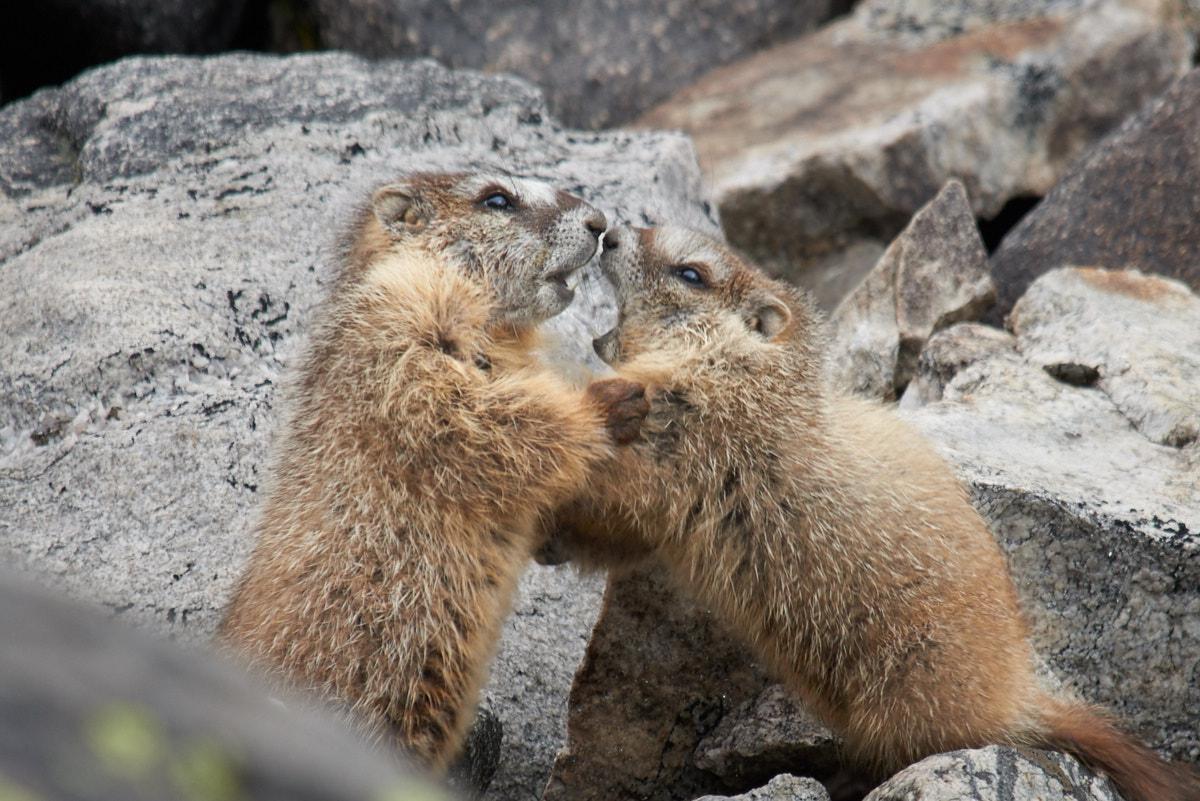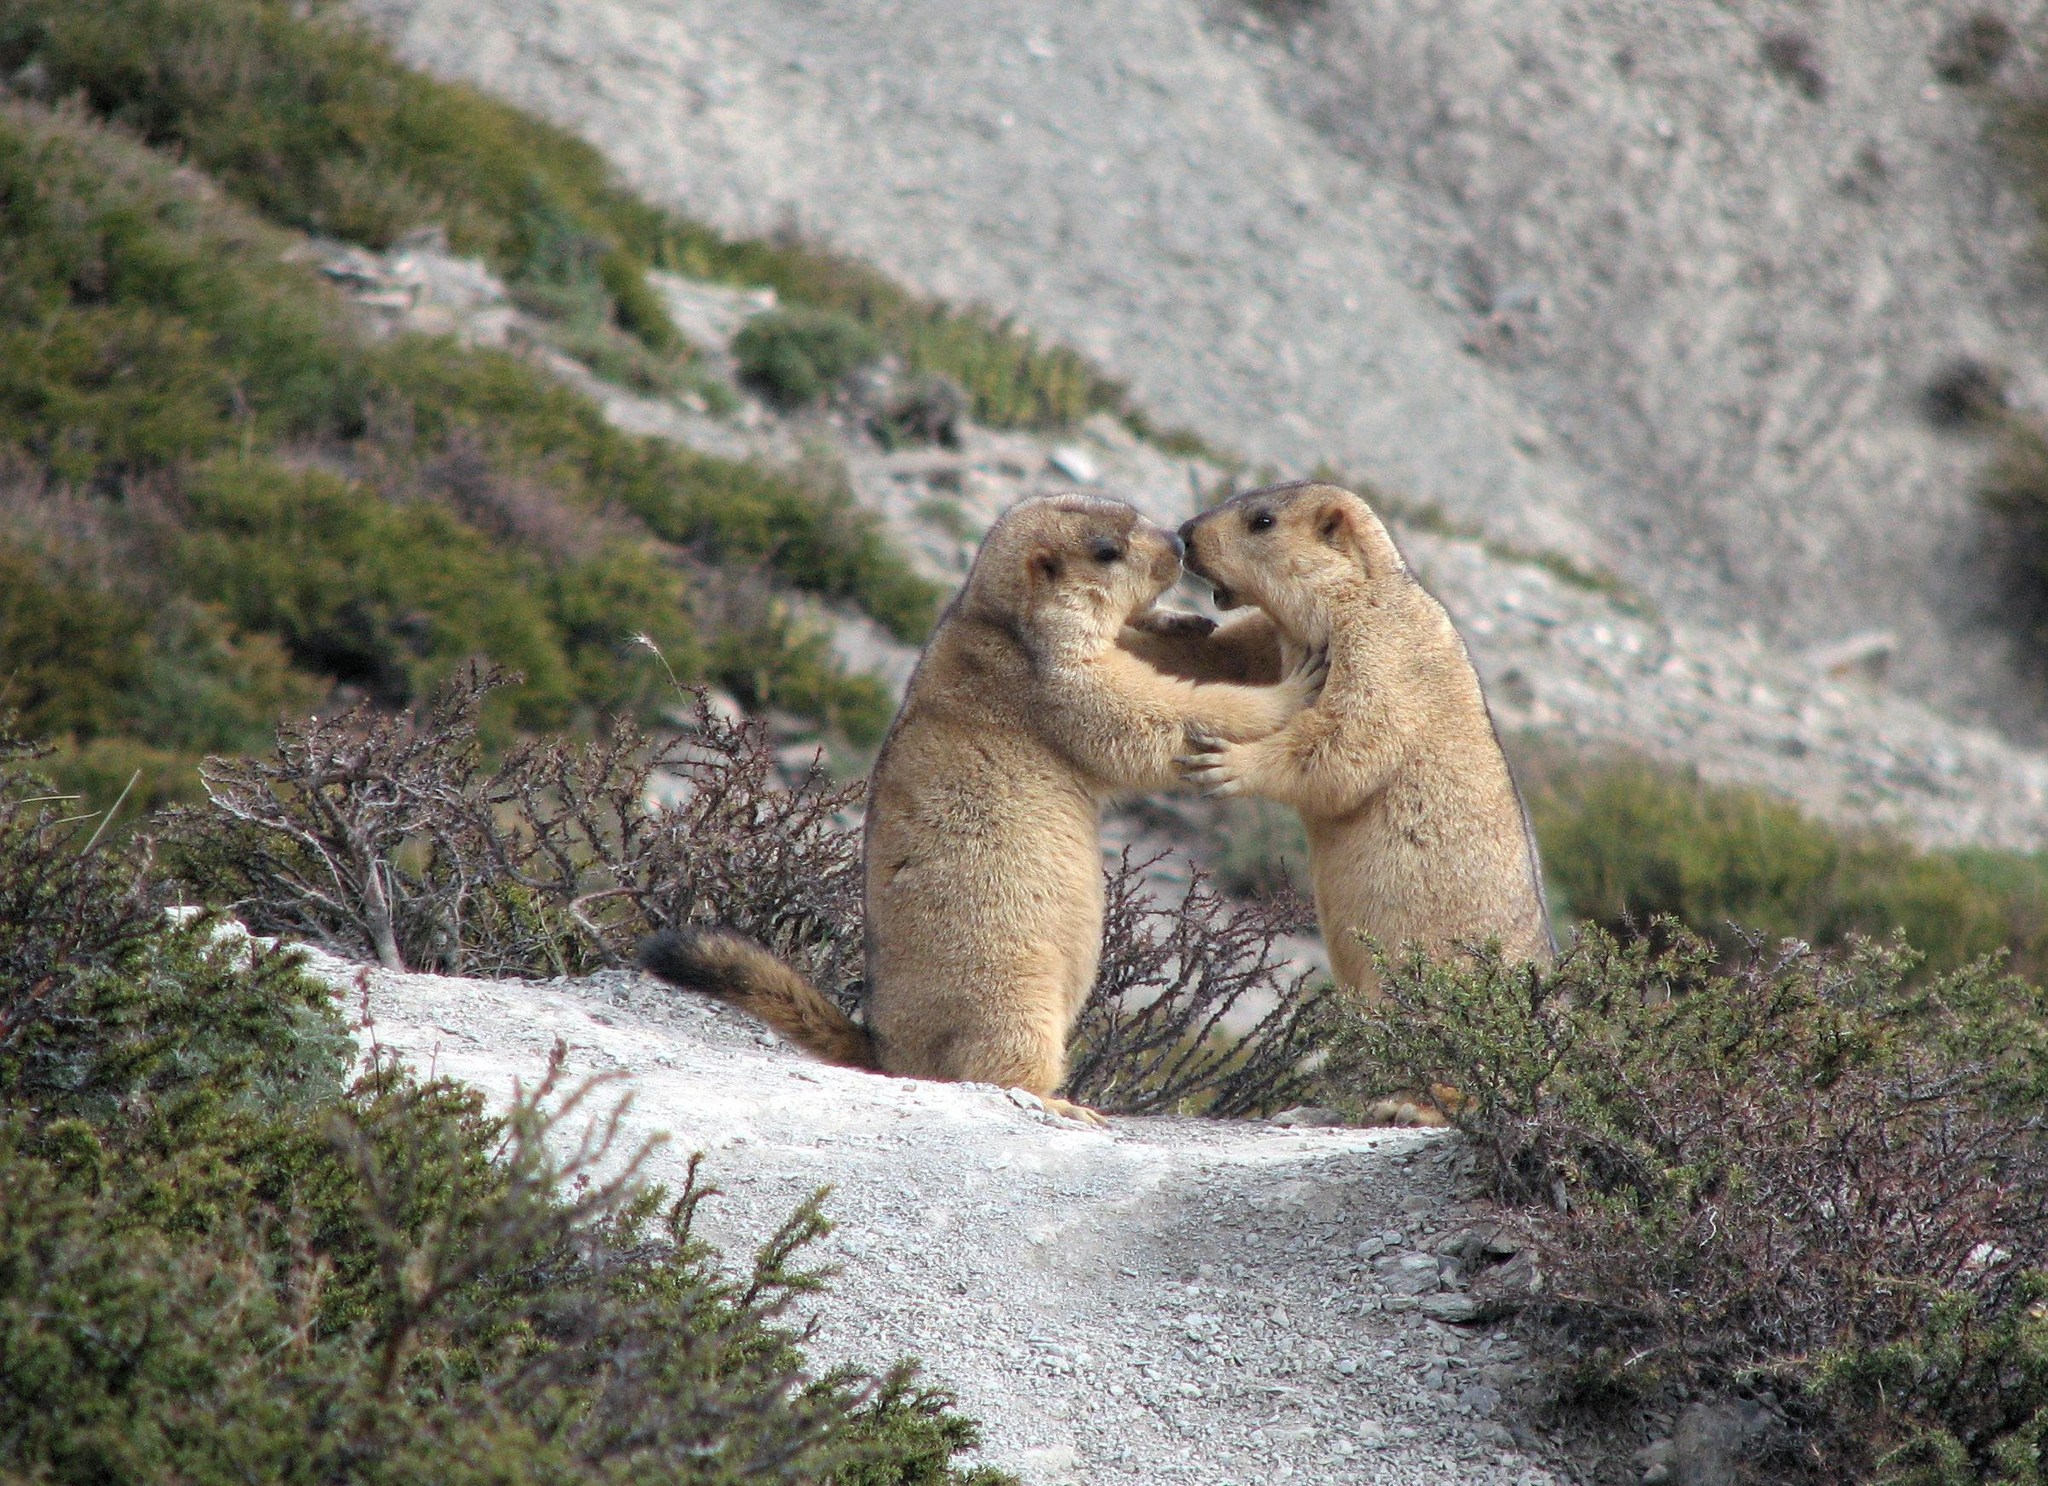The first image is the image on the left, the second image is the image on the right. Analyze the images presented: Is the assertion "At least one image includes at least two fully upright marmots with front paws touching another marmot." valid? Answer yes or no. Yes. The first image is the image on the left, the second image is the image on the right. Assess this claim about the two images: "Each image contains two animals, and at least two of the animals are touching.". Correct or not? Answer yes or no. Yes. 